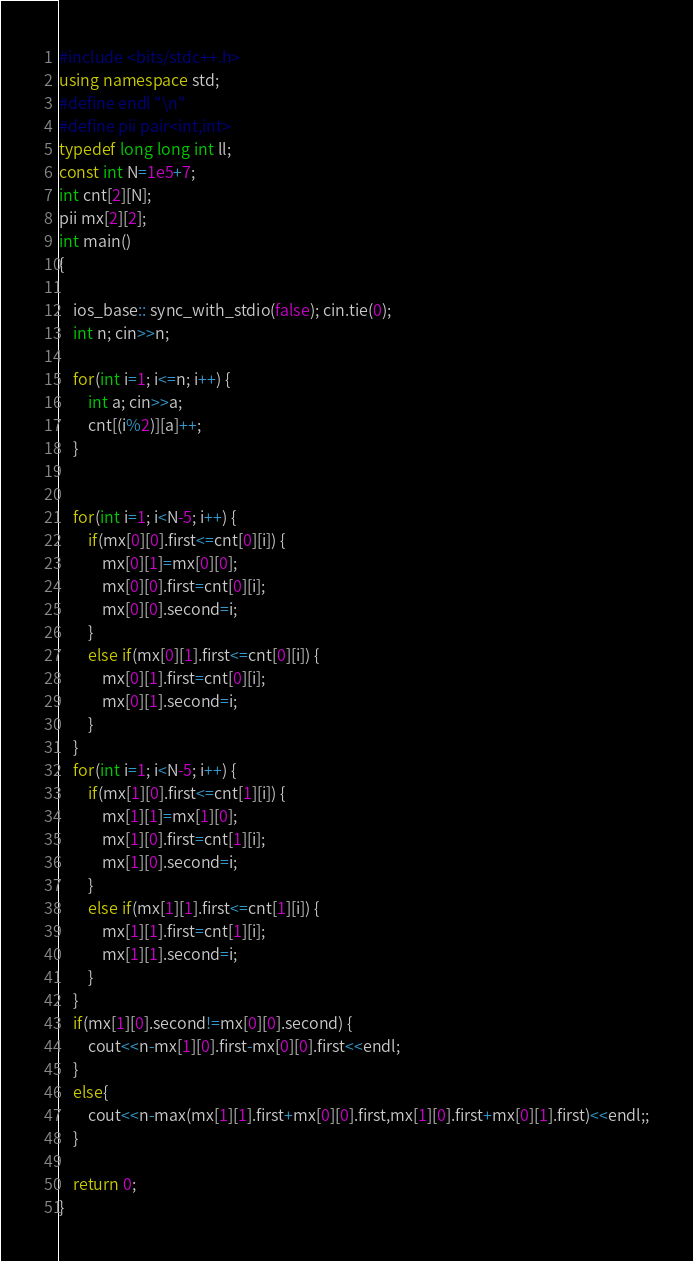Convert code to text. <code><loc_0><loc_0><loc_500><loc_500><_C++_>#include <bits/stdc++.h>
using namespace std;
#define endl "\n"
#define pii pair<int,int>
typedef long long int ll;
const int N=1e5+7;
int cnt[2][N];
pii mx[2][2];
int main()
{

	ios_base:: sync_with_stdio(false); cin.tie(0);
	int n; cin>>n;

	for(int i=1; i<=n; i++) {
		int a; cin>>a;
		cnt[(i%2)][a]++;
	}


	for(int i=1; i<N-5; i++) {
		if(mx[0][0].first<=cnt[0][i]) {
			mx[0][1]=mx[0][0];
			mx[0][0].first=cnt[0][i];
			mx[0][0].second=i;
		}
		else if(mx[0][1].first<=cnt[0][i]) {
			mx[0][1].first=cnt[0][i];
			mx[0][1].second=i;
		}
	}
	for(int i=1; i<N-5; i++) {
		if(mx[1][0].first<=cnt[1][i]) {
			mx[1][1]=mx[1][0];
			mx[1][0].first=cnt[1][i];
			mx[1][0].second=i;
		}
		else if(mx[1][1].first<=cnt[1][i]) {
			mx[1][1].first=cnt[1][i];
			mx[1][1].second=i;
		}
	}
	if(mx[1][0].second!=mx[0][0].second) {
		cout<<n-mx[1][0].first-mx[0][0].first<<endl;
	}
	else{
		cout<<n-max(mx[1][1].first+mx[0][0].first,mx[1][0].first+mx[0][1].first)<<endl;;
	}

	return 0;
}
</code> 